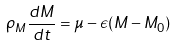<formula> <loc_0><loc_0><loc_500><loc_500>\rho _ { M } \frac { d M } { d t } = \mu - \epsilon ( M - M _ { 0 } )</formula> 